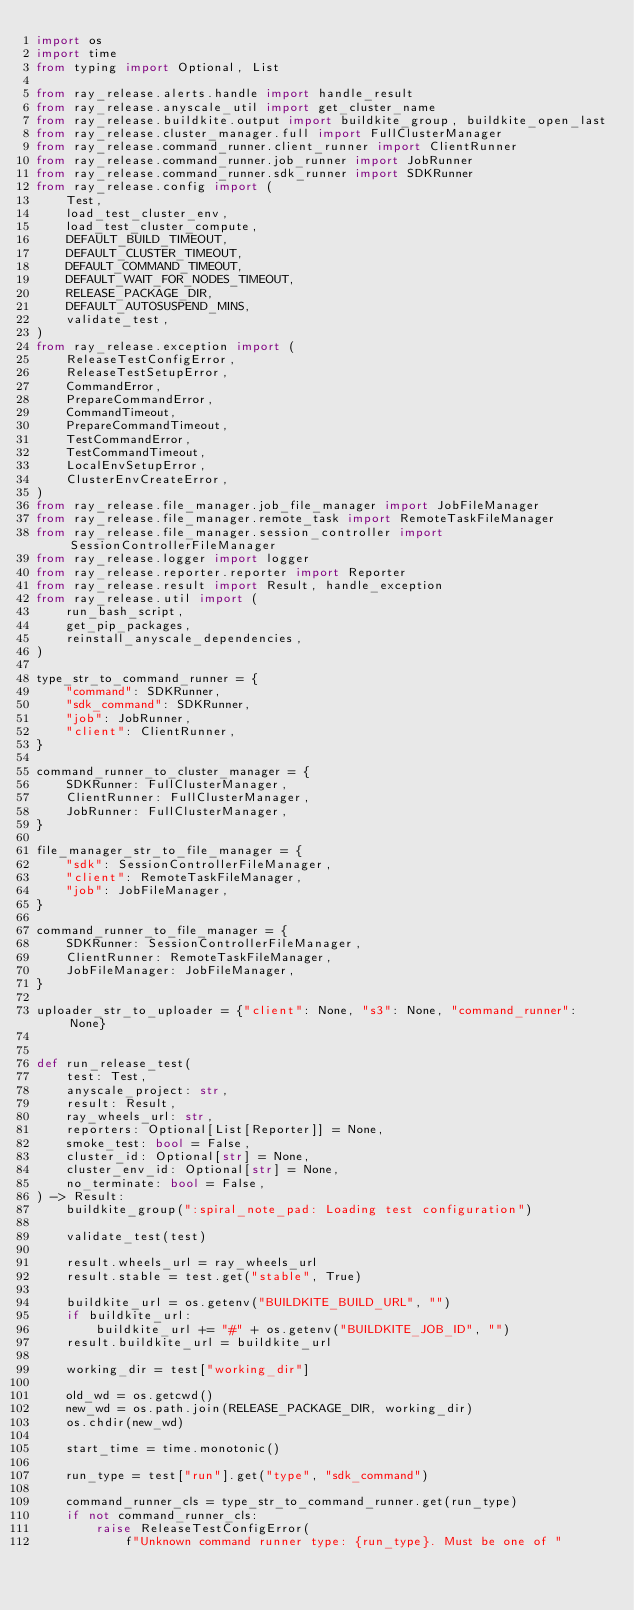<code> <loc_0><loc_0><loc_500><loc_500><_Python_>import os
import time
from typing import Optional, List

from ray_release.alerts.handle import handle_result
from ray_release.anyscale_util import get_cluster_name
from ray_release.buildkite.output import buildkite_group, buildkite_open_last
from ray_release.cluster_manager.full import FullClusterManager
from ray_release.command_runner.client_runner import ClientRunner
from ray_release.command_runner.job_runner import JobRunner
from ray_release.command_runner.sdk_runner import SDKRunner
from ray_release.config import (
    Test,
    load_test_cluster_env,
    load_test_cluster_compute,
    DEFAULT_BUILD_TIMEOUT,
    DEFAULT_CLUSTER_TIMEOUT,
    DEFAULT_COMMAND_TIMEOUT,
    DEFAULT_WAIT_FOR_NODES_TIMEOUT,
    RELEASE_PACKAGE_DIR,
    DEFAULT_AUTOSUSPEND_MINS,
    validate_test,
)
from ray_release.exception import (
    ReleaseTestConfigError,
    ReleaseTestSetupError,
    CommandError,
    PrepareCommandError,
    CommandTimeout,
    PrepareCommandTimeout,
    TestCommandError,
    TestCommandTimeout,
    LocalEnvSetupError,
    ClusterEnvCreateError,
)
from ray_release.file_manager.job_file_manager import JobFileManager
from ray_release.file_manager.remote_task import RemoteTaskFileManager
from ray_release.file_manager.session_controller import SessionControllerFileManager
from ray_release.logger import logger
from ray_release.reporter.reporter import Reporter
from ray_release.result import Result, handle_exception
from ray_release.util import (
    run_bash_script,
    get_pip_packages,
    reinstall_anyscale_dependencies,
)

type_str_to_command_runner = {
    "command": SDKRunner,
    "sdk_command": SDKRunner,
    "job": JobRunner,
    "client": ClientRunner,
}

command_runner_to_cluster_manager = {
    SDKRunner: FullClusterManager,
    ClientRunner: FullClusterManager,
    JobRunner: FullClusterManager,
}

file_manager_str_to_file_manager = {
    "sdk": SessionControllerFileManager,
    "client": RemoteTaskFileManager,
    "job": JobFileManager,
}

command_runner_to_file_manager = {
    SDKRunner: SessionControllerFileManager,
    ClientRunner: RemoteTaskFileManager,
    JobFileManager: JobFileManager,
}

uploader_str_to_uploader = {"client": None, "s3": None, "command_runner": None}


def run_release_test(
    test: Test,
    anyscale_project: str,
    result: Result,
    ray_wheels_url: str,
    reporters: Optional[List[Reporter]] = None,
    smoke_test: bool = False,
    cluster_id: Optional[str] = None,
    cluster_env_id: Optional[str] = None,
    no_terminate: bool = False,
) -> Result:
    buildkite_group(":spiral_note_pad: Loading test configuration")

    validate_test(test)

    result.wheels_url = ray_wheels_url
    result.stable = test.get("stable", True)

    buildkite_url = os.getenv("BUILDKITE_BUILD_URL", "")
    if buildkite_url:
        buildkite_url += "#" + os.getenv("BUILDKITE_JOB_ID", "")
    result.buildkite_url = buildkite_url

    working_dir = test["working_dir"]

    old_wd = os.getcwd()
    new_wd = os.path.join(RELEASE_PACKAGE_DIR, working_dir)
    os.chdir(new_wd)

    start_time = time.monotonic()

    run_type = test["run"].get("type", "sdk_command")

    command_runner_cls = type_str_to_command_runner.get(run_type)
    if not command_runner_cls:
        raise ReleaseTestConfigError(
            f"Unknown command runner type: {run_type}. Must be one of "</code> 